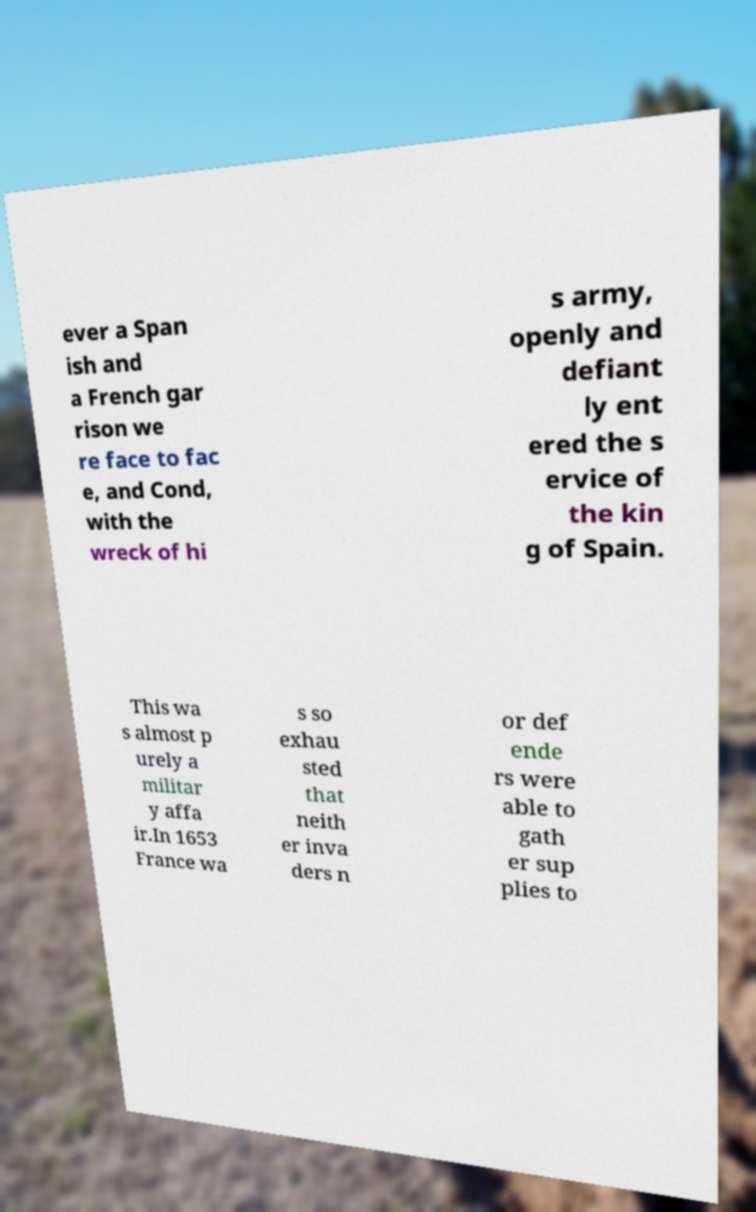What messages or text are displayed in this image? I need them in a readable, typed format. ever a Span ish and a French gar rison we re face to fac e, and Cond, with the wreck of hi s army, openly and defiant ly ent ered the s ervice of the kin g of Spain. This wa s almost p urely a militar y affa ir.In 1653 France wa s so exhau sted that neith er inva ders n or def ende rs were able to gath er sup plies to 